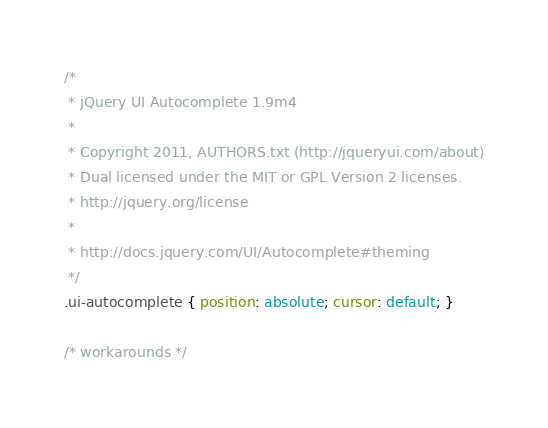<code> <loc_0><loc_0><loc_500><loc_500><_CSS_>/*
 * jQuery UI Autocomplete 1.9m4
 *
 * Copyright 2011, AUTHORS.txt (http://jqueryui.com/about)
 * Dual licensed under the MIT or GPL Version 2 licenses.
 * http://jquery.org/license
 *
 * http://docs.jquery.com/UI/Autocomplete#theming
 */
.ui-autocomplete { position: absolute; cursor: default; }	

/* workarounds */</code> 